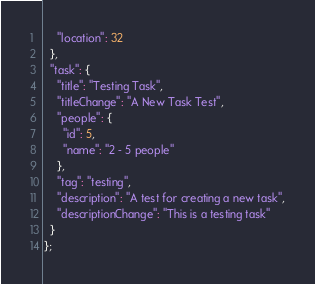<code> <loc_0><loc_0><loc_500><loc_500><_JavaScript_>    "location": 32
  },
  "task": {
    "title": "Testing Task",
    "titleChange": "A New Task Test",
    "people": {
      "id": 5,
      "name": "2 - 5 people"
    },
    "tag": "testing",
    "description": "A test for creating a new task",
    "descriptionChange": "This is a testing task"
  }
};
</code> 